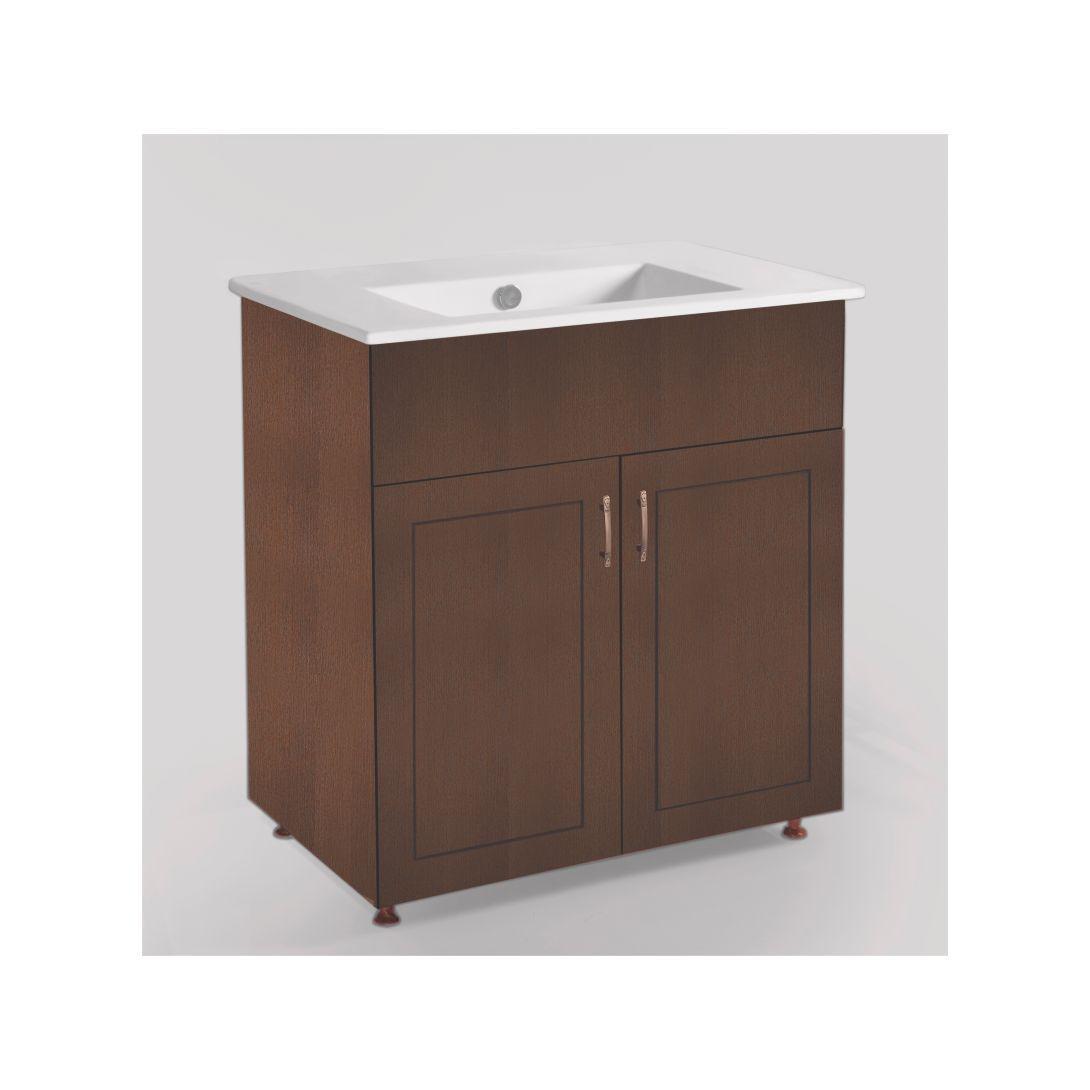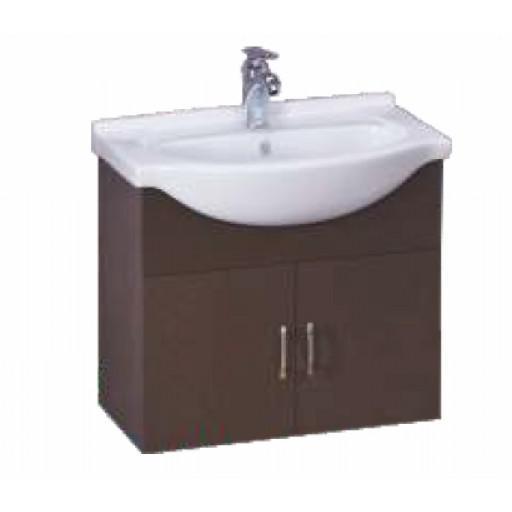The first image is the image on the left, the second image is the image on the right. Evaluate the accuracy of this statement regarding the images: "In both images, a chrome faucet is centered at the back of the bathroom sink unit.". Is it true? Answer yes or no. No. 